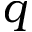<formula> <loc_0><loc_0><loc_500><loc_500>q</formula> 